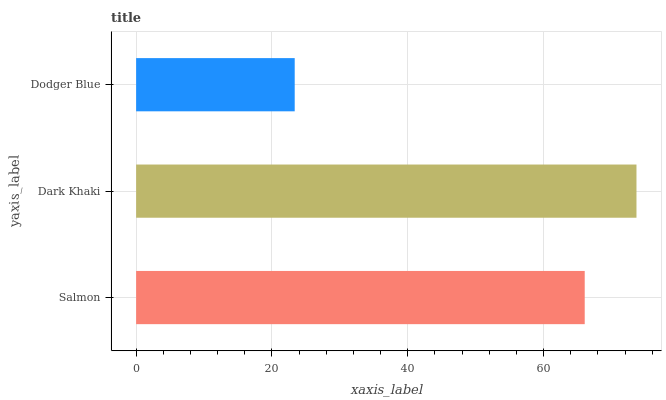Is Dodger Blue the minimum?
Answer yes or no. Yes. Is Dark Khaki the maximum?
Answer yes or no. Yes. Is Dark Khaki the minimum?
Answer yes or no. No. Is Dodger Blue the maximum?
Answer yes or no. No. Is Dark Khaki greater than Dodger Blue?
Answer yes or no. Yes. Is Dodger Blue less than Dark Khaki?
Answer yes or no. Yes. Is Dodger Blue greater than Dark Khaki?
Answer yes or no. No. Is Dark Khaki less than Dodger Blue?
Answer yes or no. No. Is Salmon the high median?
Answer yes or no. Yes. Is Salmon the low median?
Answer yes or no. Yes. Is Dark Khaki the high median?
Answer yes or no. No. Is Dark Khaki the low median?
Answer yes or no. No. 